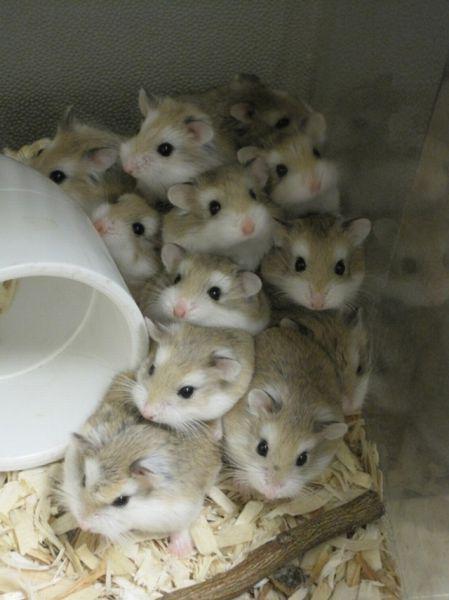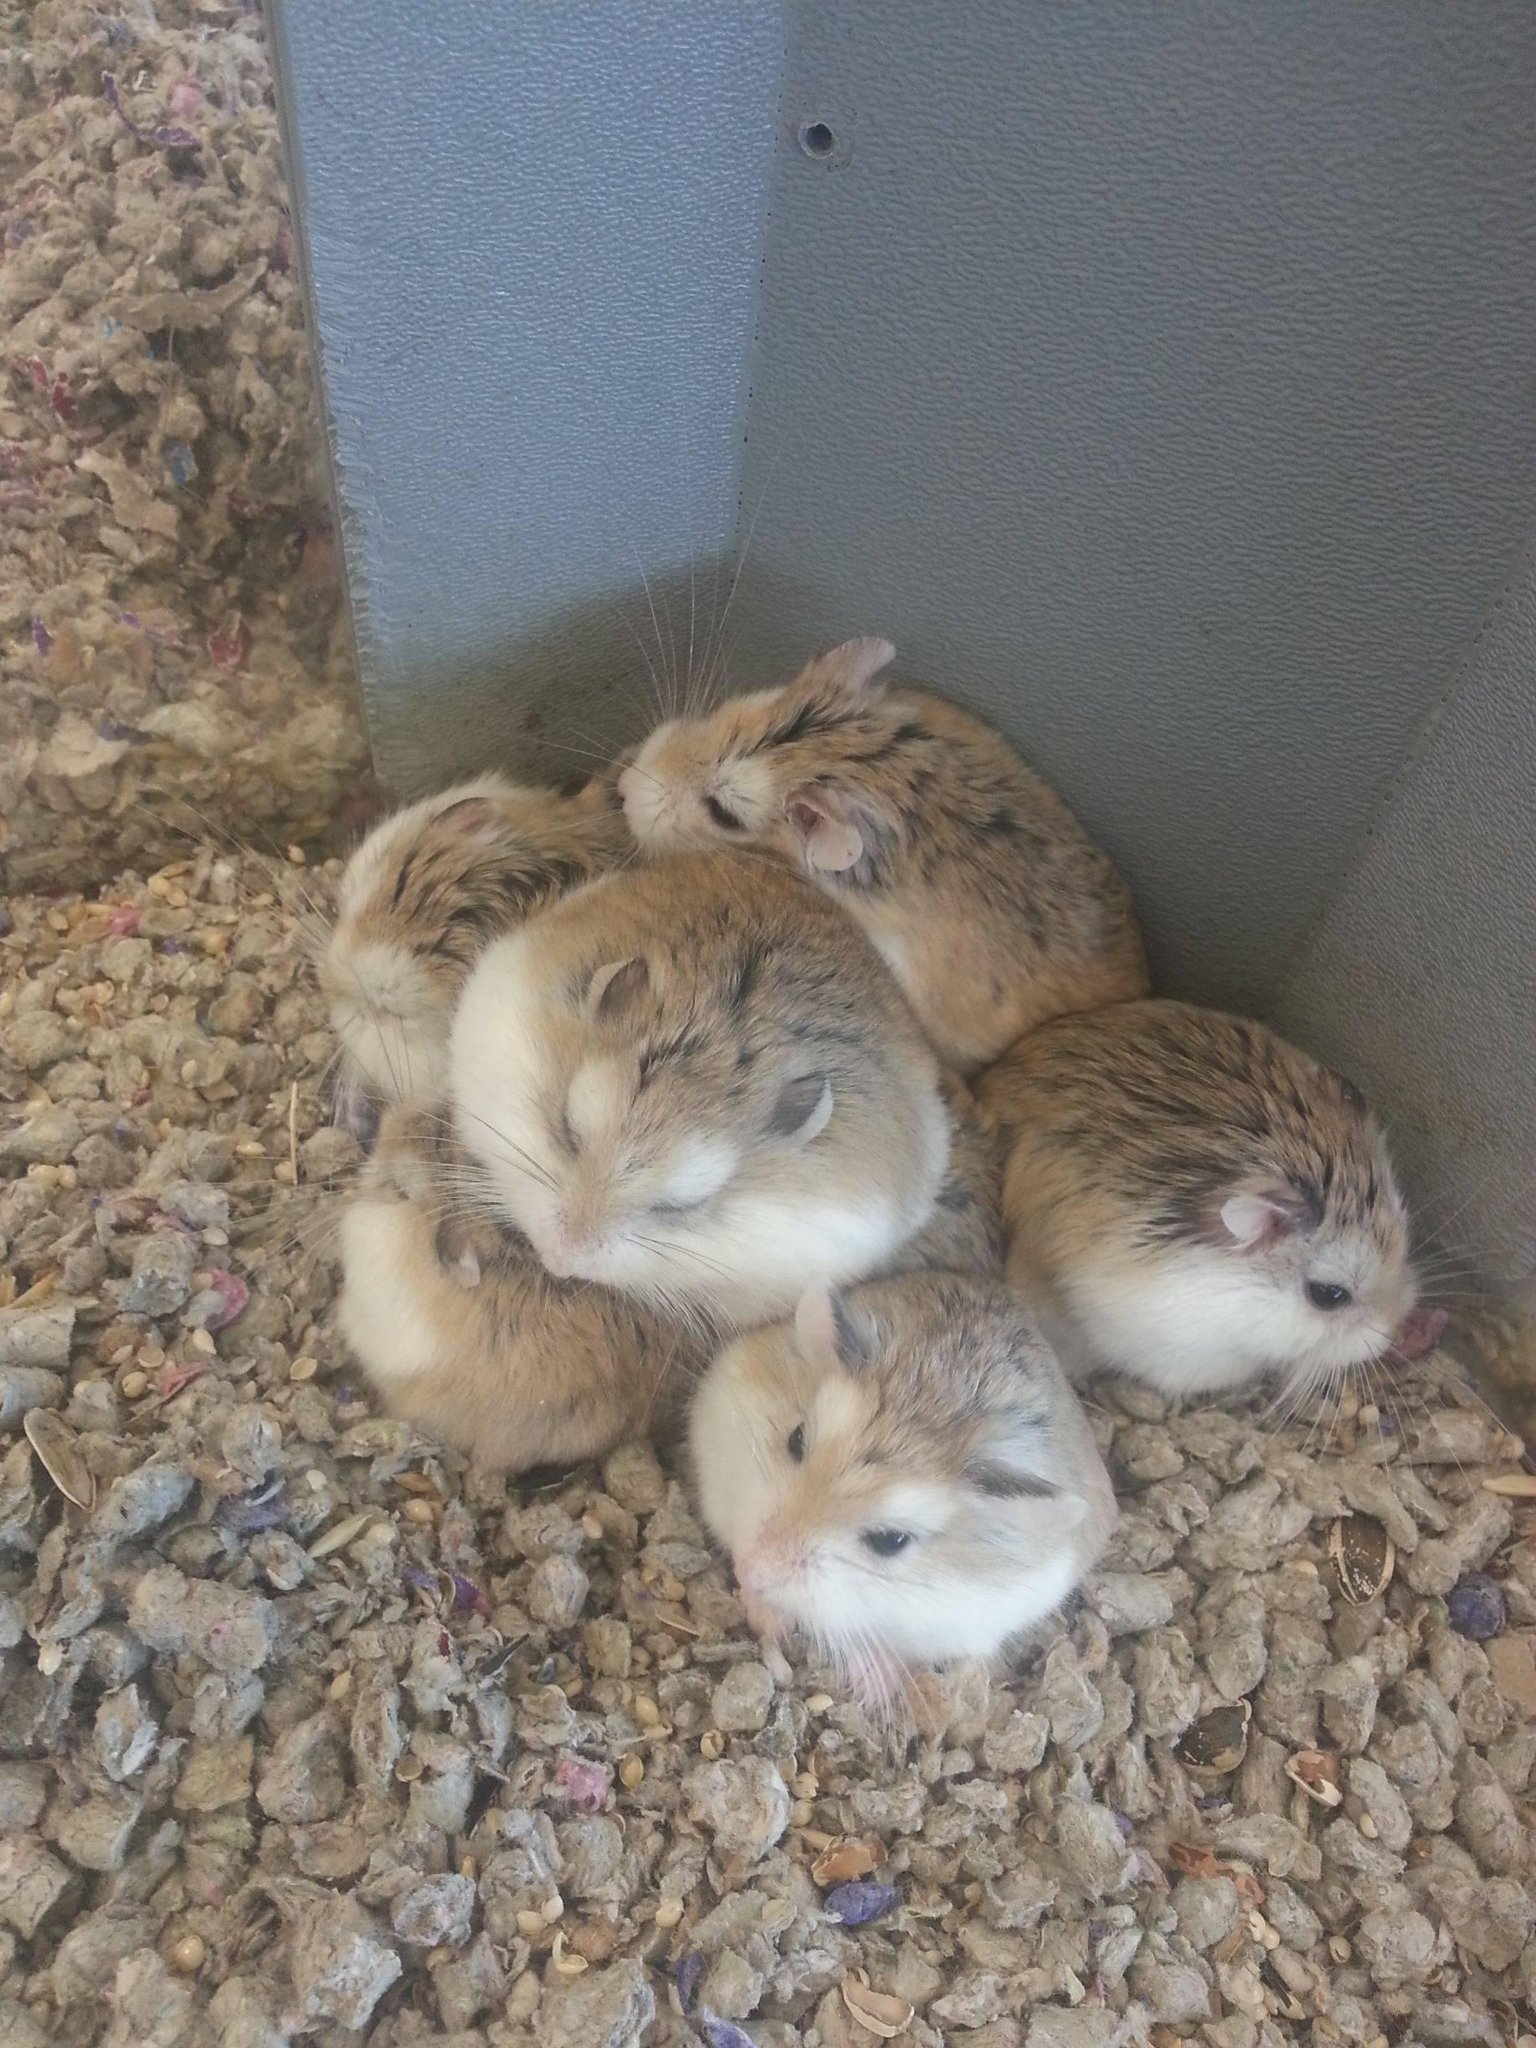The first image is the image on the left, the second image is the image on the right. Given the left and right images, does the statement "The right image contains at least one rodent standing on a blue cloth." hold true? Answer yes or no. No. The first image is the image on the left, the second image is the image on the right. Examine the images to the left and right. Is the description "One of the images shows several gerbils peeking their heads out of a ceramic bath." accurate? Answer yes or no. No. 